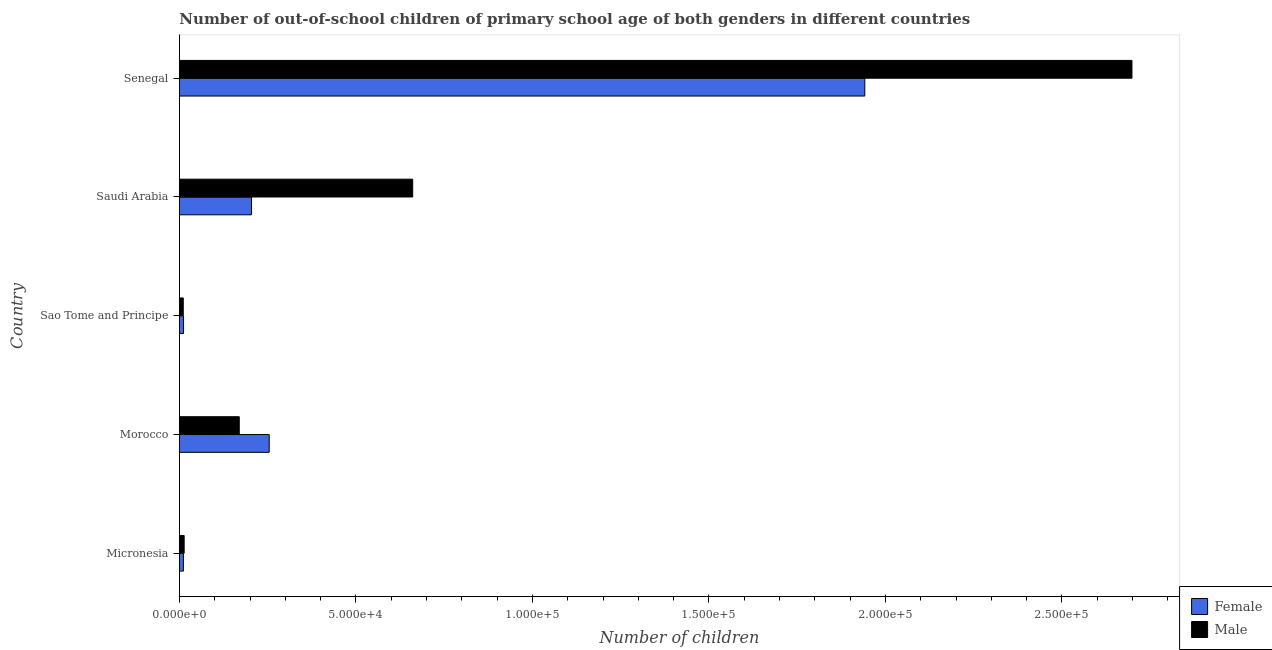How many different coloured bars are there?
Give a very brief answer. 2. Are the number of bars on each tick of the Y-axis equal?
Provide a short and direct response. Yes. What is the label of the 2nd group of bars from the top?
Make the answer very short. Saudi Arabia. In how many cases, is the number of bars for a given country not equal to the number of legend labels?
Give a very brief answer. 0. What is the number of female out-of-school students in Saudi Arabia?
Make the answer very short. 2.04e+04. Across all countries, what is the maximum number of male out-of-school students?
Offer a very short reply. 2.70e+05. Across all countries, what is the minimum number of female out-of-school students?
Provide a succinct answer. 1127. In which country was the number of female out-of-school students maximum?
Offer a very short reply. Senegal. In which country was the number of female out-of-school students minimum?
Offer a very short reply. Micronesia. What is the total number of male out-of-school students in the graph?
Your answer should be compact. 3.55e+05. What is the difference between the number of female out-of-school students in Micronesia and that in Morocco?
Provide a short and direct response. -2.43e+04. What is the difference between the number of female out-of-school students in Senegal and the number of male out-of-school students in Morocco?
Your answer should be very brief. 1.77e+05. What is the average number of male out-of-school students per country?
Offer a very short reply. 7.11e+04. What is the difference between the number of male out-of-school students and number of female out-of-school students in Micronesia?
Provide a short and direct response. 216. In how many countries, is the number of male out-of-school students greater than 230000 ?
Offer a very short reply. 1. What is the ratio of the number of female out-of-school students in Sao Tome and Principe to that in Senegal?
Provide a short and direct response. 0.01. Is the number of female out-of-school students in Micronesia less than that in Senegal?
Ensure brevity in your answer.  Yes. Is the difference between the number of female out-of-school students in Morocco and Senegal greater than the difference between the number of male out-of-school students in Morocco and Senegal?
Your answer should be compact. Yes. What is the difference between the highest and the second highest number of female out-of-school students?
Provide a succinct answer. 1.69e+05. What is the difference between the highest and the lowest number of male out-of-school students?
Offer a terse response. 2.69e+05. In how many countries, is the number of female out-of-school students greater than the average number of female out-of-school students taken over all countries?
Offer a terse response. 1. What does the 2nd bar from the bottom in Saudi Arabia represents?
Ensure brevity in your answer.  Male. Are all the bars in the graph horizontal?
Your response must be concise. Yes. Does the graph contain any zero values?
Your response must be concise. No. Does the graph contain grids?
Keep it short and to the point. No. What is the title of the graph?
Provide a short and direct response. Number of out-of-school children of primary school age of both genders in different countries. What is the label or title of the X-axis?
Keep it short and to the point. Number of children. What is the Number of children of Female in Micronesia?
Your answer should be compact. 1127. What is the Number of children of Male in Micronesia?
Offer a terse response. 1343. What is the Number of children of Female in Morocco?
Provide a succinct answer. 2.54e+04. What is the Number of children of Male in Morocco?
Provide a succinct answer. 1.70e+04. What is the Number of children of Female in Sao Tome and Principe?
Provide a short and direct response. 1169. What is the Number of children in Male in Sao Tome and Principe?
Give a very brief answer. 1093. What is the Number of children of Female in Saudi Arabia?
Your response must be concise. 2.04e+04. What is the Number of children of Male in Saudi Arabia?
Give a very brief answer. 6.61e+04. What is the Number of children of Female in Senegal?
Offer a very short reply. 1.94e+05. What is the Number of children in Male in Senegal?
Your answer should be very brief. 2.70e+05. Across all countries, what is the maximum Number of children of Female?
Provide a short and direct response. 1.94e+05. Across all countries, what is the maximum Number of children in Male?
Make the answer very short. 2.70e+05. Across all countries, what is the minimum Number of children in Female?
Your answer should be compact. 1127. Across all countries, what is the minimum Number of children of Male?
Keep it short and to the point. 1093. What is the total Number of children in Female in the graph?
Give a very brief answer. 2.42e+05. What is the total Number of children of Male in the graph?
Provide a succinct answer. 3.55e+05. What is the difference between the Number of children of Female in Micronesia and that in Morocco?
Provide a succinct answer. -2.43e+04. What is the difference between the Number of children of Male in Micronesia and that in Morocco?
Your response must be concise. -1.56e+04. What is the difference between the Number of children of Female in Micronesia and that in Sao Tome and Principe?
Ensure brevity in your answer.  -42. What is the difference between the Number of children in Male in Micronesia and that in Sao Tome and Principe?
Offer a very short reply. 250. What is the difference between the Number of children of Female in Micronesia and that in Saudi Arabia?
Keep it short and to the point. -1.93e+04. What is the difference between the Number of children in Male in Micronesia and that in Saudi Arabia?
Provide a short and direct response. -6.47e+04. What is the difference between the Number of children of Female in Micronesia and that in Senegal?
Give a very brief answer. -1.93e+05. What is the difference between the Number of children of Male in Micronesia and that in Senegal?
Provide a short and direct response. -2.68e+05. What is the difference between the Number of children in Female in Morocco and that in Sao Tome and Principe?
Ensure brevity in your answer.  2.43e+04. What is the difference between the Number of children in Male in Morocco and that in Sao Tome and Principe?
Keep it short and to the point. 1.59e+04. What is the difference between the Number of children in Female in Morocco and that in Saudi Arabia?
Provide a short and direct response. 5012. What is the difference between the Number of children in Male in Morocco and that in Saudi Arabia?
Offer a terse response. -4.91e+04. What is the difference between the Number of children of Female in Morocco and that in Senegal?
Your answer should be compact. -1.69e+05. What is the difference between the Number of children in Male in Morocco and that in Senegal?
Your answer should be compact. -2.53e+05. What is the difference between the Number of children in Female in Sao Tome and Principe and that in Saudi Arabia?
Ensure brevity in your answer.  -1.93e+04. What is the difference between the Number of children of Male in Sao Tome and Principe and that in Saudi Arabia?
Provide a succinct answer. -6.50e+04. What is the difference between the Number of children in Female in Sao Tome and Principe and that in Senegal?
Provide a succinct answer. -1.93e+05. What is the difference between the Number of children in Male in Sao Tome and Principe and that in Senegal?
Provide a short and direct response. -2.69e+05. What is the difference between the Number of children of Female in Saudi Arabia and that in Senegal?
Your response must be concise. -1.74e+05. What is the difference between the Number of children of Male in Saudi Arabia and that in Senegal?
Offer a terse response. -2.04e+05. What is the difference between the Number of children of Female in Micronesia and the Number of children of Male in Morocco?
Offer a very short reply. -1.58e+04. What is the difference between the Number of children of Female in Micronesia and the Number of children of Male in Saudi Arabia?
Provide a succinct answer. -6.50e+04. What is the difference between the Number of children in Female in Micronesia and the Number of children in Male in Senegal?
Give a very brief answer. -2.69e+05. What is the difference between the Number of children in Female in Morocco and the Number of children in Male in Sao Tome and Principe?
Provide a succinct answer. 2.43e+04. What is the difference between the Number of children in Female in Morocco and the Number of children in Male in Saudi Arabia?
Give a very brief answer. -4.06e+04. What is the difference between the Number of children of Female in Morocco and the Number of children of Male in Senegal?
Your answer should be compact. -2.44e+05. What is the difference between the Number of children of Female in Sao Tome and Principe and the Number of children of Male in Saudi Arabia?
Provide a short and direct response. -6.49e+04. What is the difference between the Number of children in Female in Sao Tome and Principe and the Number of children in Male in Senegal?
Provide a succinct answer. -2.69e+05. What is the difference between the Number of children in Female in Saudi Arabia and the Number of children in Male in Senegal?
Make the answer very short. -2.49e+05. What is the average Number of children of Female per country?
Ensure brevity in your answer.  4.85e+04. What is the average Number of children in Male per country?
Offer a very short reply. 7.11e+04. What is the difference between the Number of children in Female and Number of children in Male in Micronesia?
Keep it short and to the point. -216. What is the difference between the Number of children of Female and Number of children of Male in Morocco?
Provide a short and direct response. 8486. What is the difference between the Number of children of Female and Number of children of Male in Sao Tome and Principe?
Your answer should be compact. 76. What is the difference between the Number of children in Female and Number of children in Male in Saudi Arabia?
Your answer should be compact. -4.57e+04. What is the difference between the Number of children in Female and Number of children in Male in Senegal?
Offer a terse response. -7.57e+04. What is the ratio of the Number of children of Female in Micronesia to that in Morocco?
Your response must be concise. 0.04. What is the ratio of the Number of children in Male in Micronesia to that in Morocco?
Make the answer very short. 0.08. What is the ratio of the Number of children in Female in Micronesia to that in Sao Tome and Principe?
Offer a very short reply. 0.96. What is the ratio of the Number of children of Male in Micronesia to that in Sao Tome and Principe?
Give a very brief answer. 1.23. What is the ratio of the Number of children in Female in Micronesia to that in Saudi Arabia?
Your answer should be compact. 0.06. What is the ratio of the Number of children in Male in Micronesia to that in Saudi Arabia?
Ensure brevity in your answer.  0.02. What is the ratio of the Number of children of Female in Micronesia to that in Senegal?
Keep it short and to the point. 0.01. What is the ratio of the Number of children in Male in Micronesia to that in Senegal?
Your answer should be compact. 0.01. What is the ratio of the Number of children in Female in Morocco to that in Sao Tome and Principe?
Your response must be concise. 21.76. What is the ratio of the Number of children of Male in Morocco to that in Sao Tome and Principe?
Provide a succinct answer. 15.51. What is the ratio of the Number of children in Female in Morocco to that in Saudi Arabia?
Your answer should be very brief. 1.25. What is the ratio of the Number of children of Male in Morocco to that in Saudi Arabia?
Provide a short and direct response. 0.26. What is the ratio of the Number of children in Female in Morocco to that in Senegal?
Your answer should be very brief. 0.13. What is the ratio of the Number of children of Male in Morocco to that in Senegal?
Your response must be concise. 0.06. What is the ratio of the Number of children in Female in Sao Tome and Principe to that in Saudi Arabia?
Your answer should be compact. 0.06. What is the ratio of the Number of children of Male in Sao Tome and Principe to that in Saudi Arabia?
Offer a very short reply. 0.02. What is the ratio of the Number of children of Female in Sao Tome and Principe to that in Senegal?
Provide a succinct answer. 0.01. What is the ratio of the Number of children of Male in Sao Tome and Principe to that in Senegal?
Your response must be concise. 0. What is the ratio of the Number of children in Female in Saudi Arabia to that in Senegal?
Offer a terse response. 0.11. What is the ratio of the Number of children in Male in Saudi Arabia to that in Senegal?
Provide a succinct answer. 0.24. What is the difference between the highest and the second highest Number of children of Female?
Ensure brevity in your answer.  1.69e+05. What is the difference between the highest and the second highest Number of children of Male?
Your answer should be compact. 2.04e+05. What is the difference between the highest and the lowest Number of children of Female?
Provide a short and direct response. 1.93e+05. What is the difference between the highest and the lowest Number of children of Male?
Offer a terse response. 2.69e+05. 